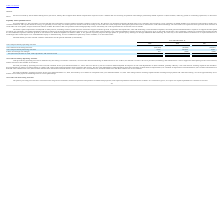From Ringcentral's financial document, What are the respective values of the cash and cash equivalents as of December 31, 2019 and 2018?  The document shows two values: $343.6 million and $566.3 million. From the document: "2019 and 2018, we had cash and cash equivalents of $343.6 million and $566.3 million, respectively. We finance our operations primarily through sales ..." Also, What are the respective net cash provided by operating activities between 2017 to 2019? The document contains multiple relevant values: $41,165, $72,130, $64,846 (in thousands). From the document: "cash provided by operating activities $ 64,846 $ 72,130 $ 41,165 vided by operating activities $ 64,846 $ 72,130 $ 41,165 Net cash provided by operati..." Also, What are the respective net cash used by financing activities between 2017 to 2019? The document contains multiple relevant values: 6,783, 397,255, 9,042 (in thousands). From the document: "Net cash provided by financing activities 9,042 397,255 6,783 Net cash provided by financing activities 9,042 397,255 6,783 sh provided by financing a..." Also, can you calculate: What is the percentage change in the net cash provided by operating activities between 2017 and 2018? To answer this question, I need to perform calculations using the financial data. The calculation is: (72,130 - 41,165)/41,165 , which equals 75.22 (percentage). This is based on the information: "vided by operating activities $ 64,846 $ 72,130 $ 41,165 cash provided by operating activities $ 64,846 $ 72,130 $ 41,165..." The key data points involved are: 41,165, 72,130. Also, can you calculate: What is the percentage change in the net cash provided by operating activities between 2018 and 2019? To answer this question, I need to perform calculations using the financial data. The calculation is: (64,846 - 72,130)/72,130 , which equals -10.1 (percentage). This is based on the information: "Net cash provided by operating activities $ 64,846 $ 72,130 $ 41,165 cash provided by operating activities $ 64,846 $ 72,130 $ 41,165..." The key data points involved are: 64,846, 72,130. Also, can you calculate: What is the total net cash provided by financing activities between 2017 to 2019? Based on the calculation: 6,783 + 397,255 + 9,042 , the result is 413080 (in thousands). This is based on the information: "Net cash provided by financing activities 9,042 397,255 6,783 Net cash provided by financing activities 9,042 397,255 6,783 sh provided by financing activities 9,042 397,255 6,783..." The key data points involved are: 397,255, 6,783, 9,042. 